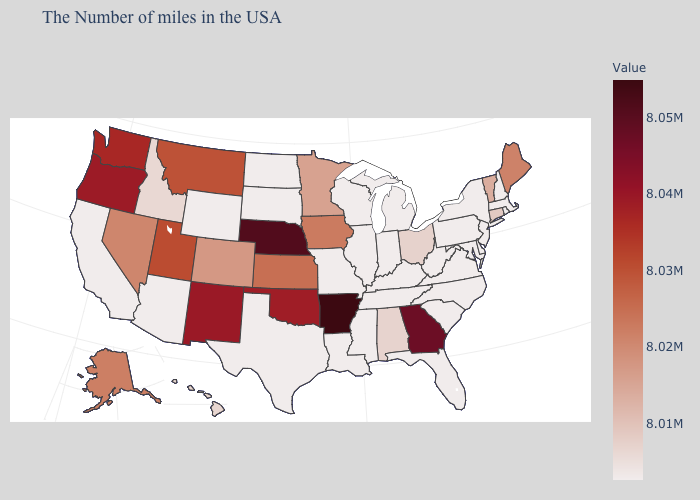Is the legend a continuous bar?
Give a very brief answer. Yes. Does Kansas have the highest value in the MidWest?
Write a very short answer. No. Which states have the lowest value in the Northeast?
Be succinct. Massachusetts, Rhode Island, New Hampshire, New York, New Jersey, Pennsylvania. Among the states that border Texas , which have the lowest value?
Give a very brief answer. Louisiana. Among the states that border Pennsylvania , does New York have the lowest value?
Keep it brief. Yes. 